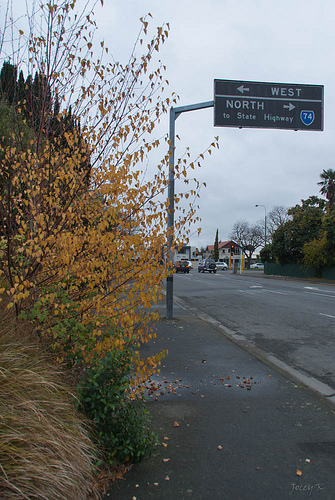<image>
Can you confirm if the tree is behind the road? No. The tree is not behind the road. From this viewpoint, the tree appears to be positioned elsewhere in the scene. 